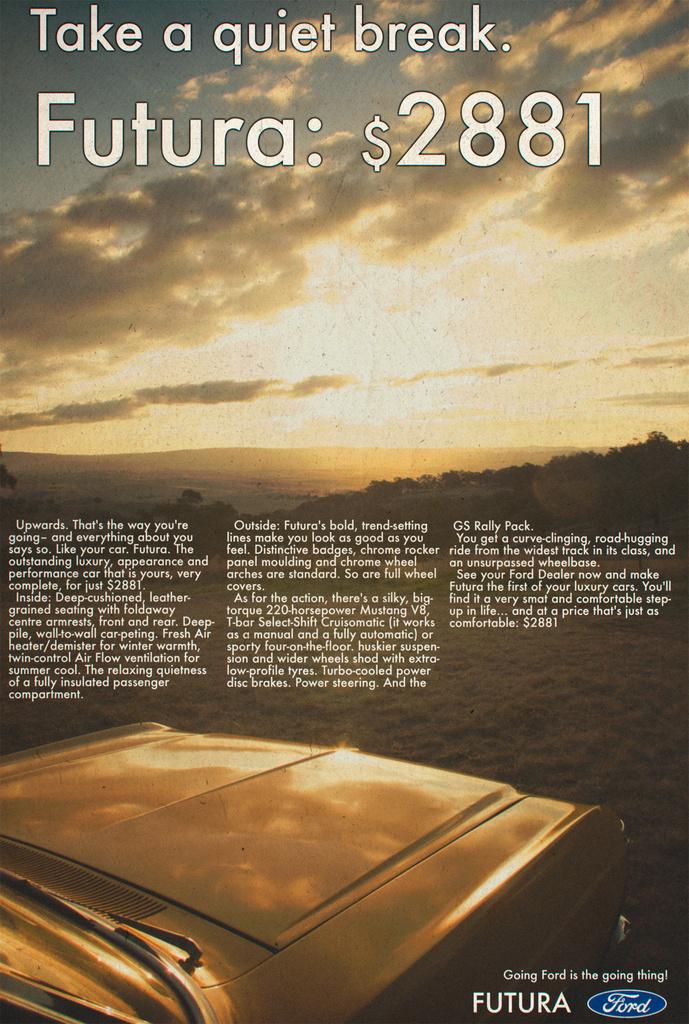What auto brand is on this flyer?
Provide a short and direct response. Ford. 